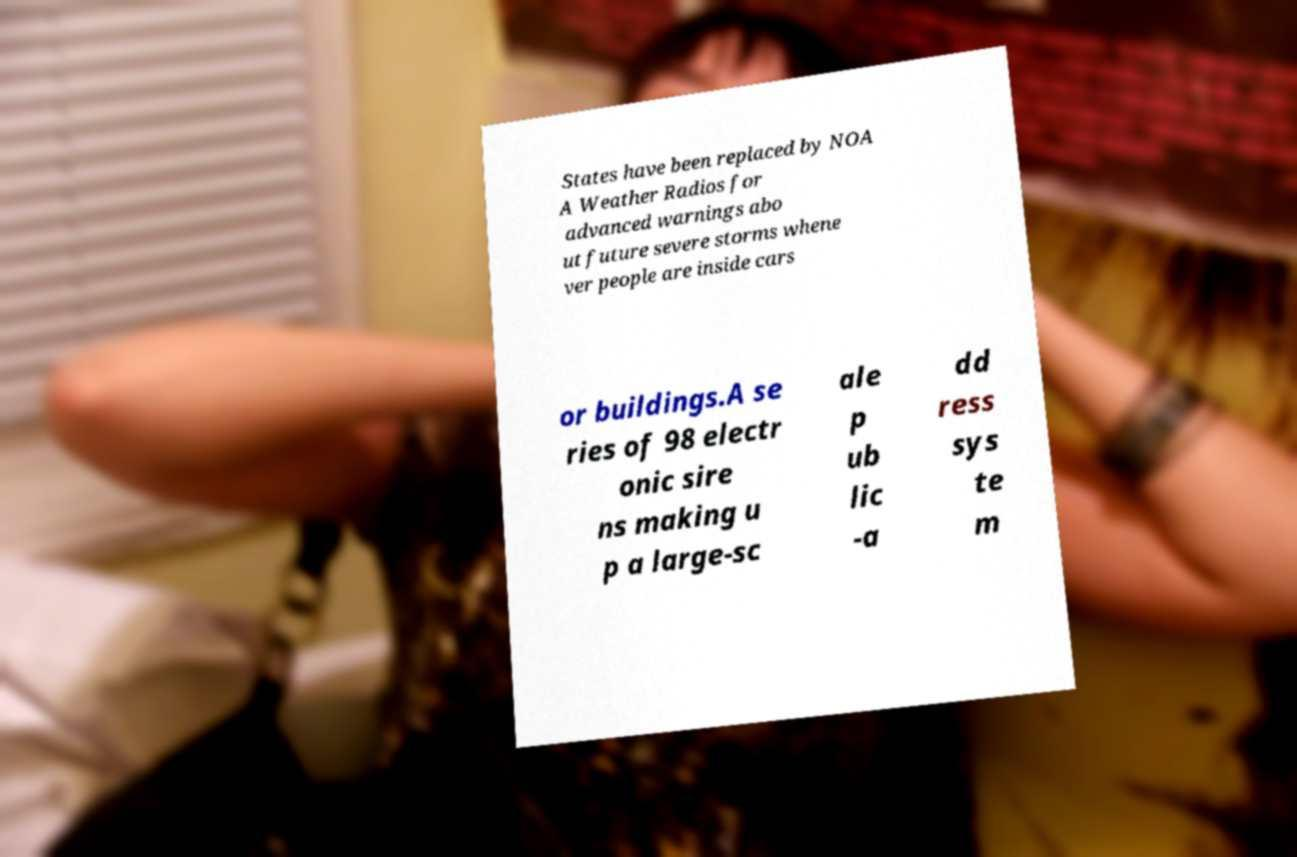Could you extract and type out the text from this image? States have been replaced by NOA A Weather Radios for advanced warnings abo ut future severe storms whene ver people are inside cars or buildings.A se ries of 98 electr onic sire ns making u p a large-sc ale p ub lic -a dd ress sys te m 